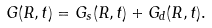<formula> <loc_0><loc_0><loc_500><loc_500>G ( { R } , t ) = G _ { s } ( { R } , t ) + G _ { d } ( { R } , t ) .</formula> 